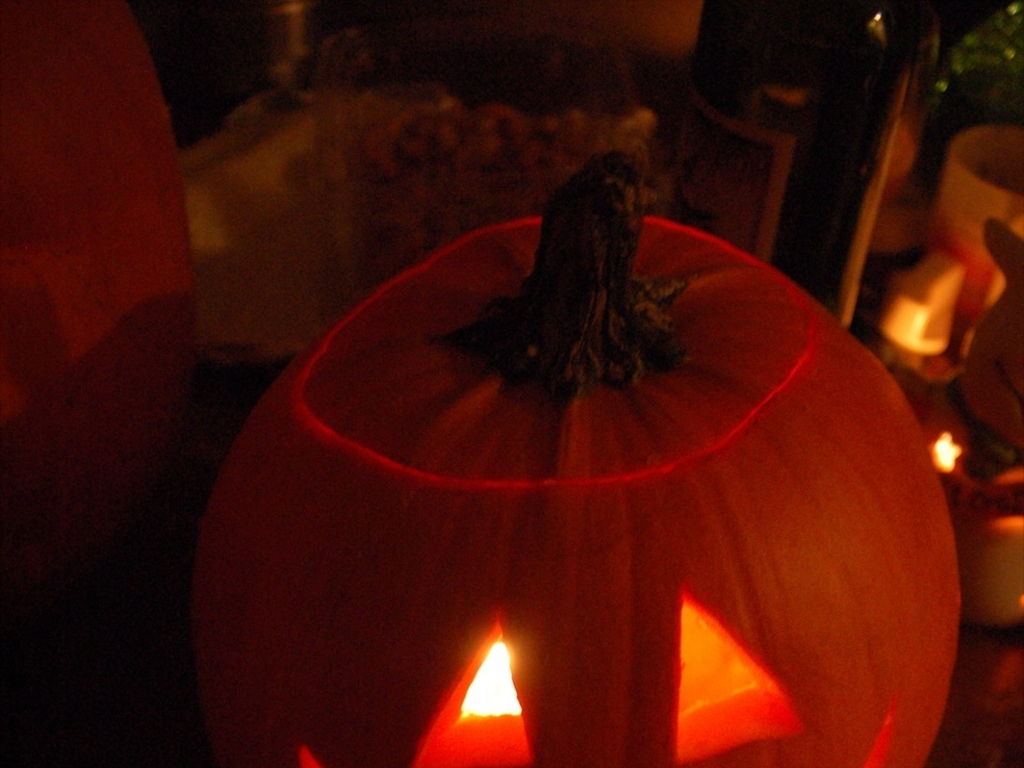How clear is the subject, the pumpkin lantern?
A. Clear
B. Indistinct
C. Blurry
D. Uncertain
Answer with the option's letter from the given choices directly. The subject, which is the pumpkin lantern, exhibits a significant level of clarity. With the internal light casting a soft glow through the carved features, each detail, including the triangular eyes and the jagged mouth, is distinguishable despite the low ambient lighting around it. Therefore, the most accurate description of the pumpkin lantern's visibility in the image is clear, corresponding to option A. 